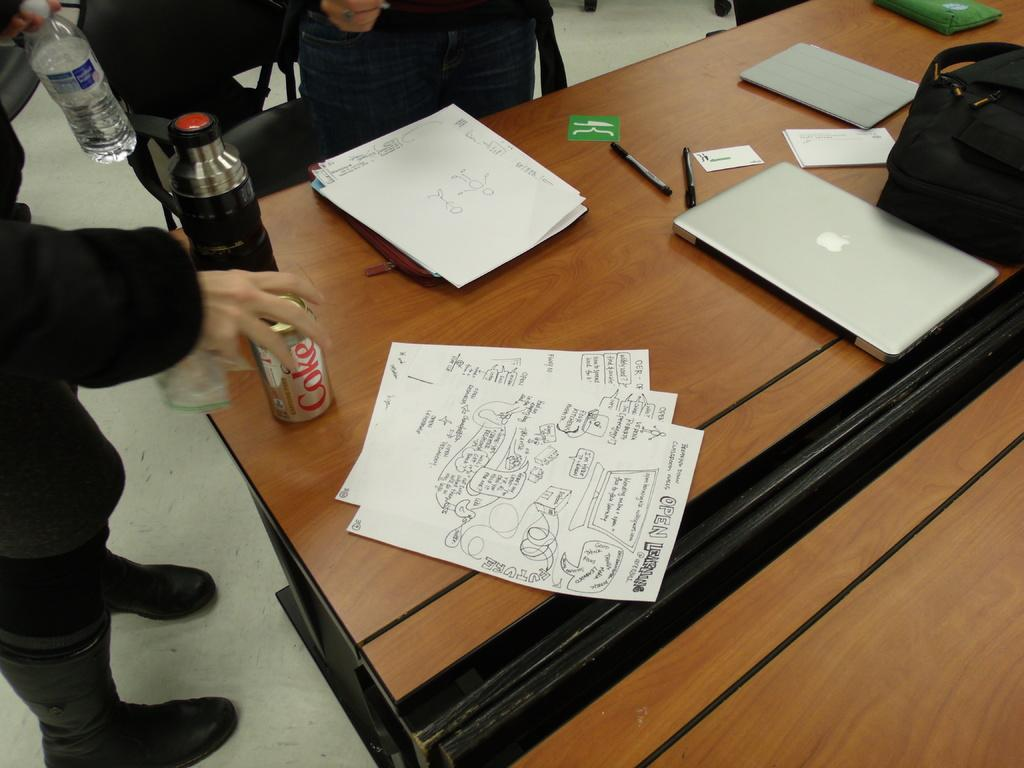What piece of furniture is present in the image? There is a table in the image. What objects can be seen on the table? There is a tin, a bottle, papers, a laptop, bags, and pens on the table. How many persons are standing in the image? Two persons are standing in the image. What can be seen in the background of the image? There are chairs visible in the background. What type of peace agreement is being discussed by the committee in the image? There is no committee or peace agreement present in the image; it only features a table with various objects and two standing persons. What is the answer to the question being asked by the person holding the microphone in the image? There is no person holding a microphone or asking a question in the image. 